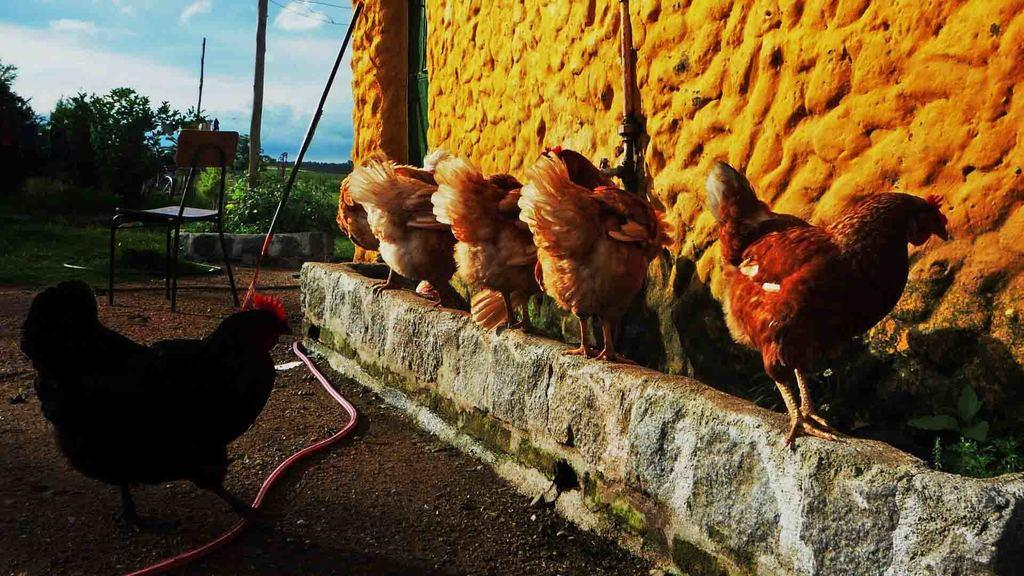What type of animal is in the image? There is a hen in the image. How many hens are visible on the right side of the image? There are five hens on the right side of the image. What is located on the right side of the image? There is a wall on the right side of the image. What can be seen in the background of the image? Trees and the sky are visible in the background of the image. Can you describe any furniture in the image? There is a chair in the background of the image. What type of cub is attacking the hens in the image? There is no cub present in the image, and therefore no such attack can be observed. 